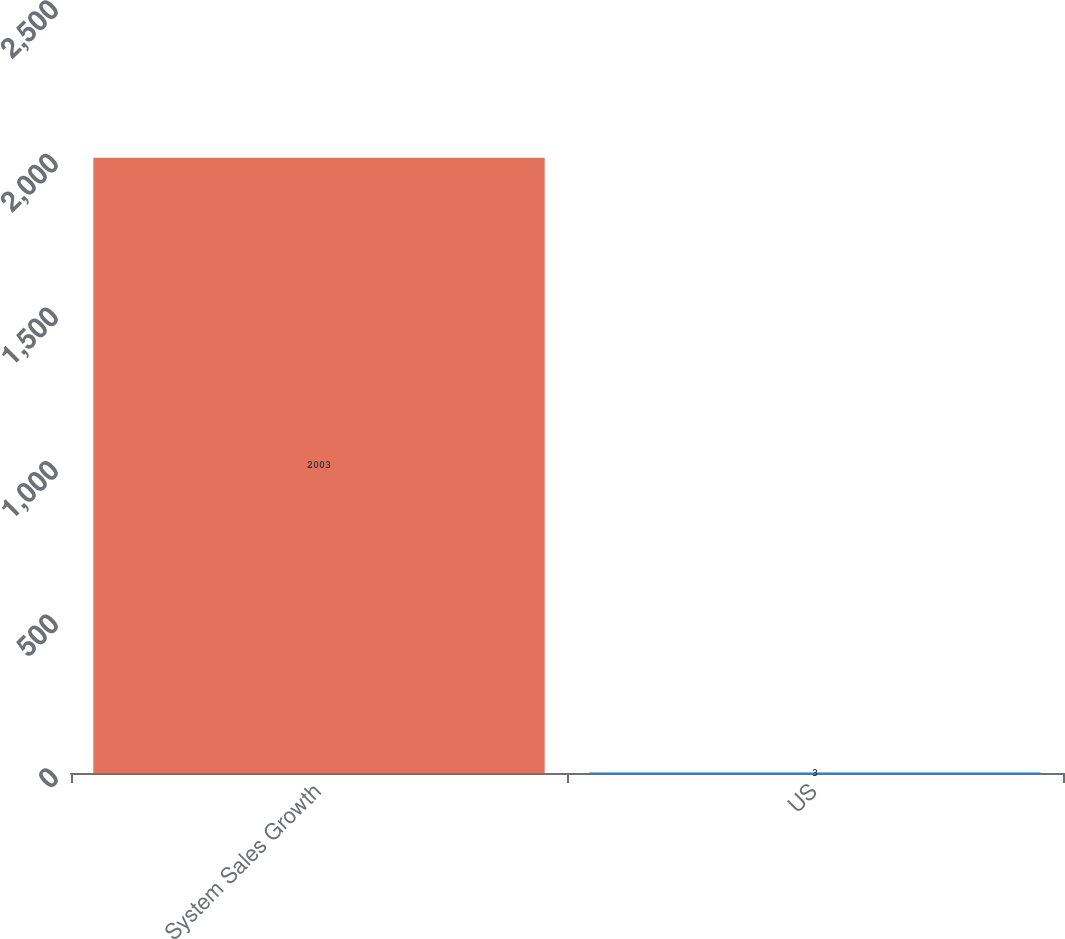Convert chart. <chart><loc_0><loc_0><loc_500><loc_500><bar_chart><fcel>System Sales Growth<fcel>US<nl><fcel>2003<fcel>3<nl></chart> 